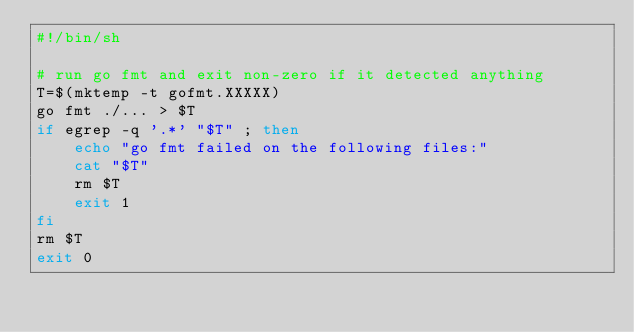Convert code to text. <code><loc_0><loc_0><loc_500><loc_500><_Bash_>#!/bin/sh

# run go fmt and exit non-zero if it detected anything
T=$(mktemp -t gofmt.XXXXX)
go fmt ./... > $T
if egrep -q '.*' "$T" ; then
	echo "go fmt failed on the following files:"
	cat "$T"
	rm $T
	exit 1
fi
rm $T
exit 0
</code> 